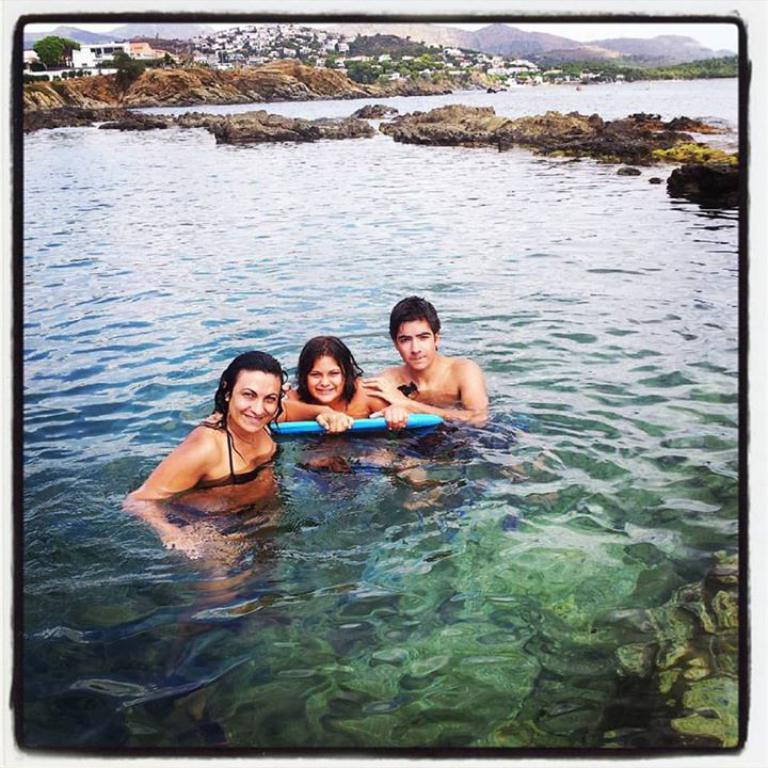What are the people in the image doing? The people in the image are in the water and holding a board. What can be seen in the background of the image? There are trees, buildings, and the sky visible in the background of the image. What type of sign can be seen on the table in the image? There is no table or sign present in the image. How many spoons are visible in the image? There are no spoons visible in the image. 